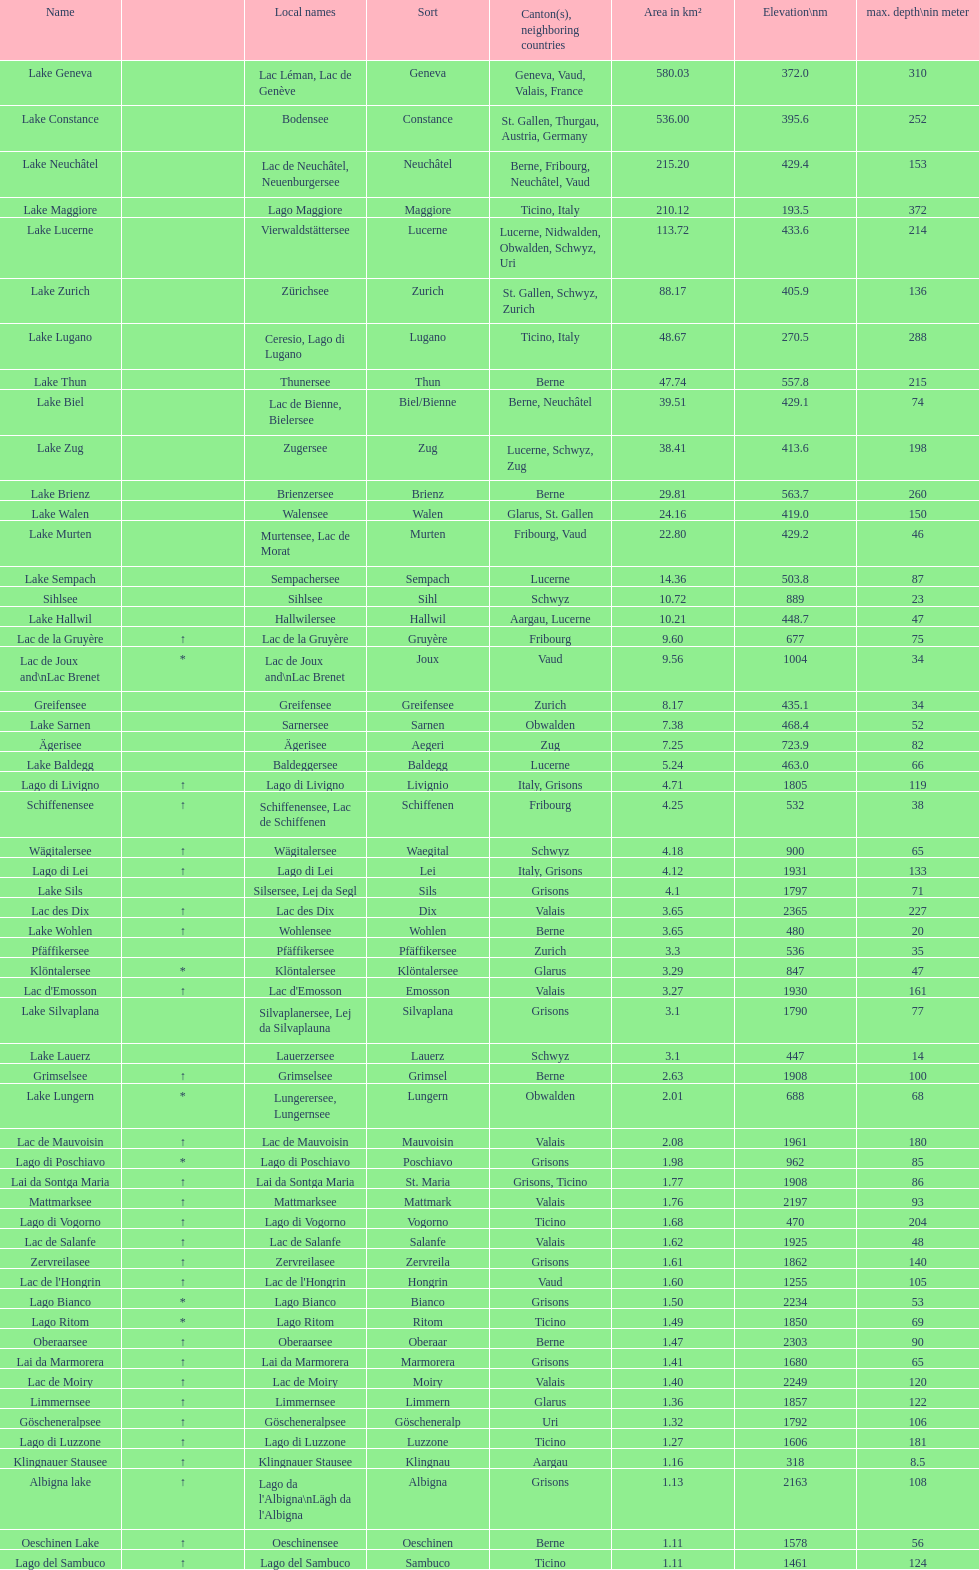Which lake has the greatest elevation? Lac des Dix. Can you give me this table as a dict? {'header': ['Name', '', 'Local names', 'Sort', 'Canton(s), neighboring countries', 'Area in km²', 'Elevation\\nm', 'max. depth\\nin meter'], 'rows': [['Lake Geneva', '', 'Lac Léman, Lac de Genève', 'Geneva', 'Geneva, Vaud, Valais, France', '580.03', '372.0', '310'], ['Lake Constance', '', 'Bodensee', 'Constance', 'St. Gallen, Thurgau, Austria, Germany', '536.00', '395.6', '252'], ['Lake Neuchâtel', '', 'Lac de Neuchâtel, Neuenburgersee', 'Neuchâtel', 'Berne, Fribourg, Neuchâtel, Vaud', '215.20', '429.4', '153'], ['Lake Maggiore', '', 'Lago Maggiore', 'Maggiore', 'Ticino, Italy', '210.12', '193.5', '372'], ['Lake Lucerne', '', 'Vierwaldstättersee', 'Lucerne', 'Lucerne, Nidwalden, Obwalden, Schwyz, Uri', '113.72', '433.6', '214'], ['Lake Zurich', '', 'Zürichsee', 'Zurich', 'St. Gallen, Schwyz, Zurich', '88.17', '405.9', '136'], ['Lake Lugano', '', 'Ceresio, Lago di Lugano', 'Lugano', 'Ticino, Italy', '48.67', '270.5', '288'], ['Lake Thun', '', 'Thunersee', 'Thun', 'Berne', '47.74', '557.8', '215'], ['Lake Biel', '', 'Lac de Bienne, Bielersee', 'Biel/Bienne', 'Berne, Neuchâtel', '39.51', '429.1', '74'], ['Lake Zug', '', 'Zugersee', 'Zug', 'Lucerne, Schwyz, Zug', '38.41', '413.6', '198'], ['Lake Brienz', '', 'Brienzersee', 'Brienz', 'Berne', '29.81', '563.7', '260'], ['Lake Walen', '', 'Walensee', 'Walen', 'Glarus, St. Gallen', '24.16', '419.0', '150'], ['Lake Murten', '', 'Murtensee, Lac de Morat', 'Murten', 'Fribourg, Vaud', '22.80', '429.2', '46'], ['Lake Sempach', '', 'Sempachersee', 'Sempach', 'Lucerne', '14.36', '503.8', '87'], ['Sihlsee', '', 'Sihlsee', 'Sihl', 'Schwyz', '10.72', '889', '23'], ['Lake Hallwil', '', 'Hallwilersee', 'Hallwil', 'Aargau, Lucerne', '10.21', '448.7', '47'], ['Lac de la Gruyère', '↑', 'Lac de la Gruyère', 'Gruyère', 'Fribourg', '9.60', '677', '75'], ['Lac de Joux and\\nLac Brenet', '*', 'Lac de Joux and\\nLac Brenet', 'Joux', 'Vaud', '9.56', '1004', '34'], ['Greifensee', '', 'Greifensee', 'Greifensee', 'Zurich', '8.17', '435.1', '34'], ['Lake Sarnen', '', 'Sarnersee', 'Sarnen', 'Obwalden', '7.38', '468.4', '52'], ['Ägerisee', '', 'Ägerisee', 'Aegeri', 'Zug', '7.25', '723.9', '82'], ['Lake Baldegg', '', 'Baldeggersee', 'Baldegg', 'Lucerne', '5.24', '463.0', '66'], ['Lago di Livigno', '↑', 'Lago di Livigno', 'Livignio', 'Italy, Grisons', '4.71', '1805', '119'], ['Schiffenensee', '↑', 'Schiffenensee, Lac de Schiffenen', 'Schiffenen', 'Fribourg', '4.25', '532', '38'], ['Wägitalersee', '↑', 'Wägitalersee', 'Waegital', 'Schwyz', '4.18', '900', '65'], ['Lago di Lei', '↑', 'Lago di Lei', 'Lei', 'Italy, Grisons', '4.12', '1931', '133'], ['Lake Sils', '', 'Silsersee, Lej da Segl', 'Sils', 'Grisons', '4.1', '1797', '71'], ['Lac des Dix', '↑', 'Lac des Dix', 'Dix', 'Valais', '3.65', '2365', '227'], ['Lake Wohlen', '↑', 'Wohlensee', 'Wohlen', 'Berne', '3.65', '480', '20'], ['Pfäffikersee', '', 'Pfäffikersee', 'Pfäffikersee', 'Zurich', '3.3', '536', '35'], ['Klöntalersee', '*', 'Klöntalersee', 'Klöntalersee', 'Glarus', '3.29', '847', '47'], ["Lac d'Emosson", '↑', "Lac d'Emosson", 'Emosson', 'Valais', '3.27', '1930', '161'], ['Lake Silvaplana', '', 'Silvaplanersee, Lej da Silvaplauna', 'Silvaplana', 'Grisons', '3.1', '1790', '77'], ['Lake Lauerz', '', 'Lauerzersee', 'Lauerz', 'Schwyz', '3.1', '447', '14'], ['Grimselsee', '↑', 'Grimselsee', 'Grimsel', 'Berne', '2.63', '1908', '100'], ['Lake Lungern', '*', 'Lungerersee, Lungernsee', 'Lungern', 'Obwalden', '2.01', '688', '68'], ['Lac de Mauvoisin', '↑', 'Lac de Mauvoisin', 'Mauvoisin', 'Valais', '2.08', '1961', '180'], ['Lago di Poschiavo', '*', 'Lago di Poschiavo', 'Poschiavo', 'Grisons', '1.98', '962', '85'], ['Lai da Sontga Maria', '↑', 'Lai da Sontga Maria', 'St. Maria', 'Grisons, Ticino', '1.77', '1908', '86'], ['Mattmarksee', '↑', 'Mattmarksee', 'Mattmark', 'Valais', '1.76', '2197', '93'], ['Lago di Vogorno', '↑', 'Lago di Vogorno', 'Vogorno', 'Ticino', '1.68', '470', '204'], ['Lac de Salanfe', '↑', 'Lac de Salanfe', 'Salanfe', 'Valais', '1.62', '1925', '48'], ['Zervreilasee', '↑', 'Zervreilasee', 'Zervreila', 'Grisons', '1.61', '1862', '140'], ["Lac de l'Hongrin", '↑', "Lac de l'Hongrin", 'Hongrin', 'Vaud', '1.60', '1255', '105'], ['Lago Bianco', '*', 'Lago Bianco', 'Bianco', 'Grisons', '1.50', '2234', '53'], ['Lago Ritom', '*', 'Lago Ritom', 'Ritom', 'Ticino', '1.49', '1850', '69'], ['Oberaarsee', '↑', 'Oberaarsee', 'Oberaar', 'Berne', '1.47', '2303', '90'], ['Lai da Marmorera', '↑', 'Lai da Marmorera', 'Marmorera', 'Grisons', '1.41', '1680', '65'], ['Lac de Moiry', '↑', 'Lac de Moiry', 'Moiry', 'Valais', '1.40', '2249', '120'], ['Limmernsee', '↑', 'Limmernsee', 'Limmern', 'Glarus', '1.36', '1857', '122'], ['Göscheneralpsee', '↑', 'Göscheneralpsee', 'Göscheneralp', 'Uri', '1.32', '1792', '106'], ['Lago di Luzzone', '↑', 'Lago di Luzzone', 'Luzzone', 'Ticino', '1.27', '1606', '181'], ['Klingnauer Stausee', '↑', 'Klingnauer Stausee', 'Klingnau', 'Aargau', '1.16', '318', '8.5'], ['Albigna lake', '↑', "Lago da l'Albigna\\nLägh da l'Albigna", 'Albigna', 'Grisons', '1.13', '2163', '108'], ['Oeschinen Lake', '↑', 'Oeschinensee', 'Oeschinen', 'Berne', '1.11', '1578', '56'], ['Lago del Sambuco', '↑', 'Lago del Sambuco', 'Sambuco', 'Ticino', '1.11', '1461', '124']]} 